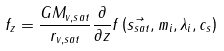<formula> <loc_0><loc_0><loc_500><loc_500>f _ { z } = \frac { G M _ { v , s a t } } { r _ { v , s a t } } \frac { \partial } { \partial z } f \left ( \vec { s _ { s a t } } , m _ { i } , \lambda _ { i } , c _ { s } \right )</formula> 